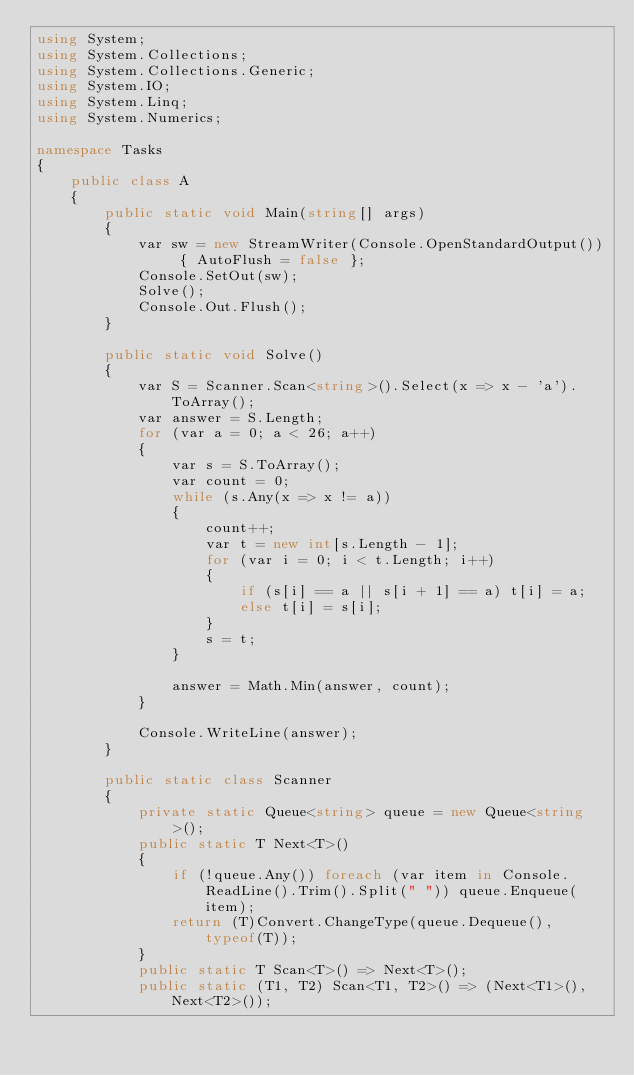<code> <loc_0><loc_0><loc_500><loc_500><_C#_>using System;
using System.Collections;
using System.Collections.Generic;
using System.IO;
using System.Linq;
using System.Numerics;

namespace Tasks
{
    public class A
    {
        public static void Main(string[] args)
        {
            var sw = new StreamWriter(Console.OpenStandardOutput()) { AutoFlush = false };
            Console.SetOut(sw);
            Solve();
            Console.Out.Flush();
        }

        public static void Solve()
        {
            var S = Scanner.Scan<string>().Select(x => x - 'a').ToArray();
            var answer = S.Length;
            for (var a = 0; a < 26; a++)
            {
                var s = S.ToArray();
                var count = 0;
                while (s.Any(x => x != a))
                {
                    count++;
                    var t = new int[s.Length - 1];
                    for (var i = 0; i < t.Length; i++)
                    {
                        if (s[i] == a || s[i + 1] == a) t[i] = a;
                        else t[i] = s[i];
                    }
                    s = t;
                }

                answer = Math.Min(answer, count);
            }

            Console.WriteLine(answer);
        }

        public static class Scanner
        {
            private static Queue<string> queue = new Queue<string>();
            public static T Next<T>()
            {
                if (!queue.Any()) foreach (var item in Console.ReadLine().Trim().Split(" ")) queue.Enqueue(item);
                return (T)Convert.ChangeType(queue.Dequeue(), typeof(T));
            }
            public static T Scan<T>() => Next<T>();
            public static (T1, T2) Scan<T1, T2>() => (Next<T1>(), Next<T2>());</code> 